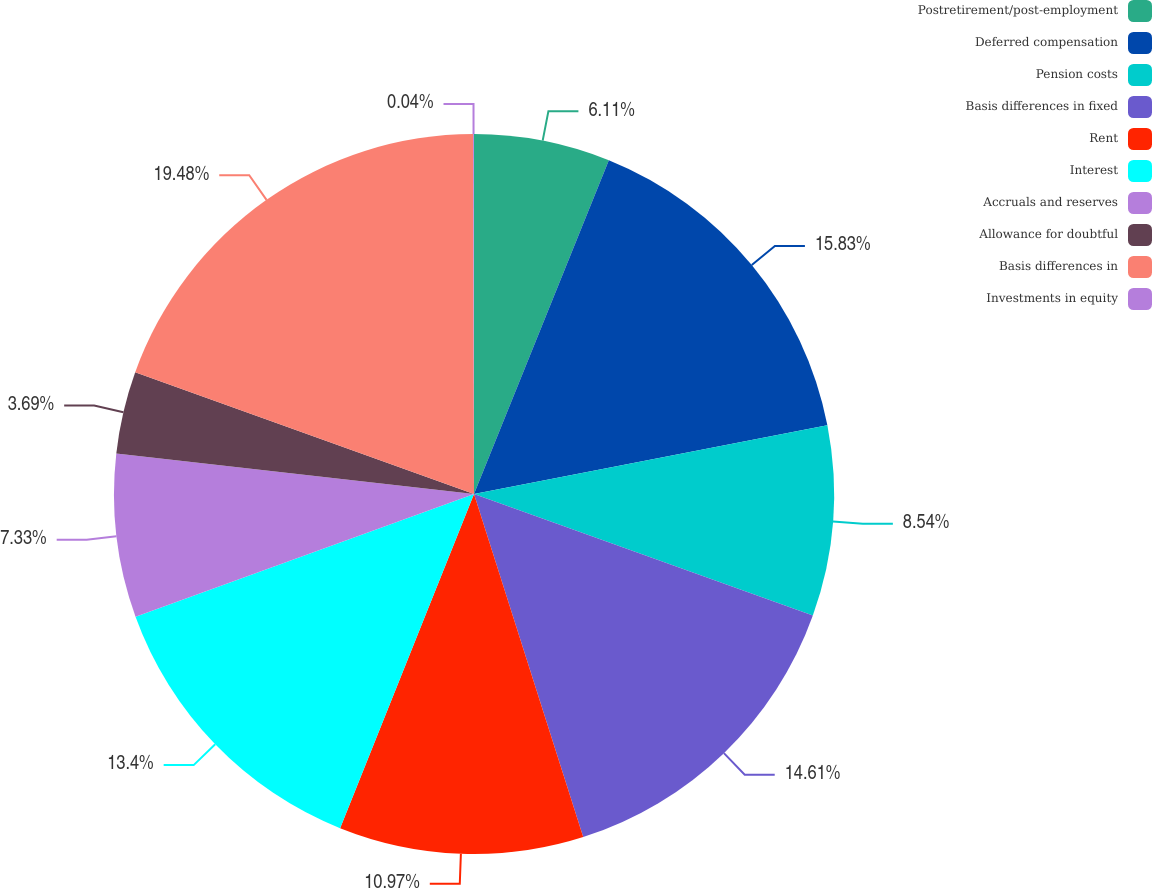<chart> <loc_0><loc_0><loc_500><loc_500><pie_chart><fcel>Postretirement/post-employment<fcel>Deferred compensation<fcel>Pension costs<fcel>Basis differences in fixed<fcel>Rent<fcel>Interest<fcel>Accruals and reserves<fcel>Allowance for doubtful<fcel>Basis differences in<fcel>Investments in equity<nl><fcel>6.11%<fcel>15.83%<fcel>8.54%<fcel>14.61%<fcel>10.97%<fcel>13.4%<fcel>7.33%<fcel>3.69%<fcel>19.47%<fcel>0.04%<nl></chart> 